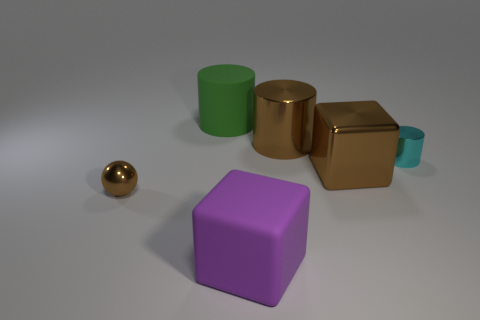Is the number of matte cylinders behind the purple matte thing less than the number of small cyan metallic objects?
Ensure brevity in your answer.  No. Do the small object behind the tiny ball and the tiny brown object have the same shape?
Provide a succinct answer. No. Are there any other things of the same color as the tiny ball?
Provide a succinct answer. Yes. There is a cylinder that is made of the same material as the large purple block; what is its size?
Your answer should be very brief. Large. There is a cyan cylinder that is behind the large metallic cube on the right side of the big metallic cylinder left of the tiny metal cylinder; what is it made of?
Offer a terse response. Metal. Are there fewer matte objects than cylinders?
Your answer should be compact. Yes. Are the big purple object and the cyan cylinder made of the same material?
Ensure brevity in your answer.  No. The large object that is the same color as the shiny cube is what shape?
Your answer should be very brief. Cylinder. Is the color of the large cylinder that is on the right side of the rubber block the same as the small cylinder?
Your answer should be compact. No. There is a metallic cylinder in front of the large brown metallic cylinder; how many brown metallic objects are to the right of it?
Your answer should be compact. 0. 